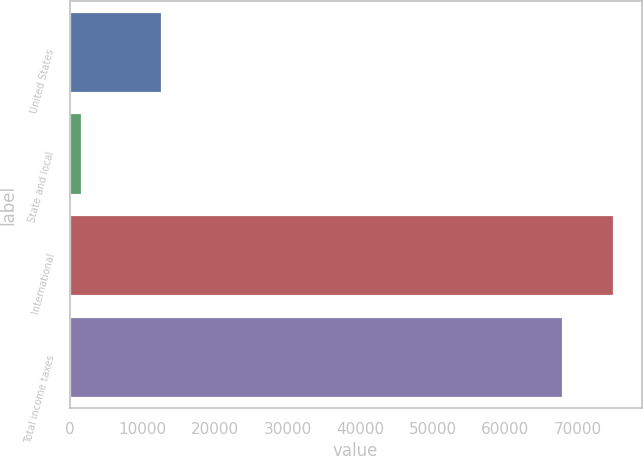Convert chart to OTSL. <chart><loc_0><loc_0><loc_500><loc_500><bar_chart><fcel>United States<fcel>State and local<fcel>International<fcel>Total income taxes<nl><fcel>12760<fcel>1677<fcel>74990.3<fcel>67894<nl></chart> 